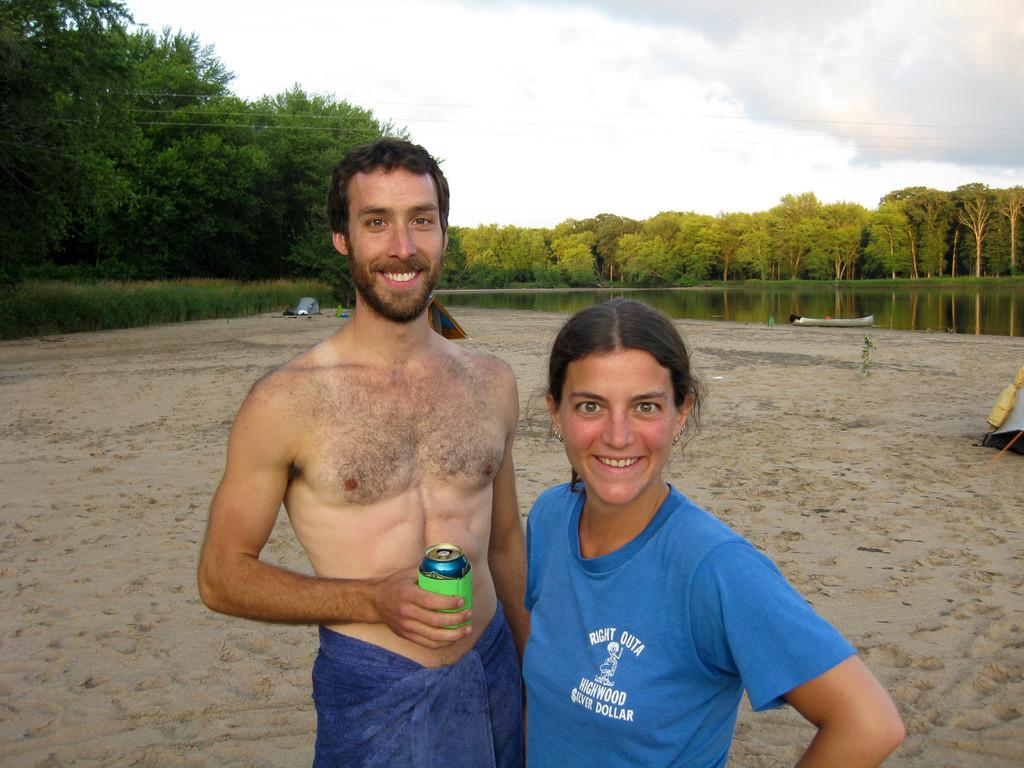How many people are in the image? There are two people in the image, a man and a woman. What are the expressions on their faces? Both the man and woman are smiling in the image. What is the man holding in the image? The man is holding a tin in the image. What can be seen in the background of the image? There are trees, water, a boat, and a tent visible in the background of the image. What word is being exchanged between the man and woman in the image? There is no indication in the image that the man and woman are exchanging words, so it cannot be determined from the picture. 